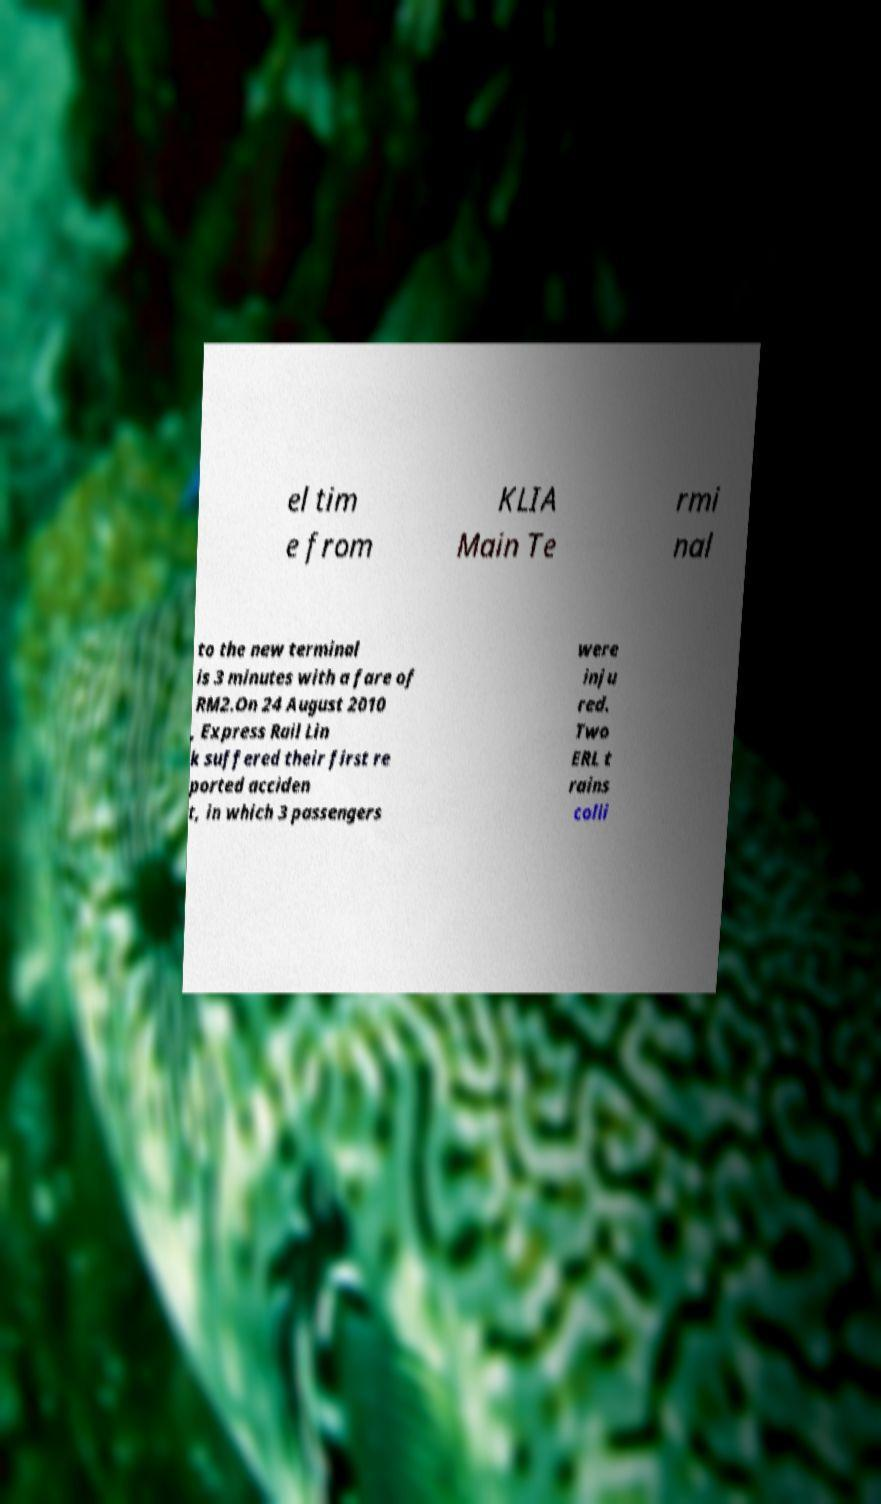There's text embedded in this image that I need extracted. Can you transcribe it verbatim? el tim e from KLIA Main Te rmi nal to the new terminal is 3 minutes with a fare of RM2.On 24 August 2010 , Express Rail Lin k suffered their first re ported acciden t, in which 3 passengers were inju red. Two ERL t rains colli 